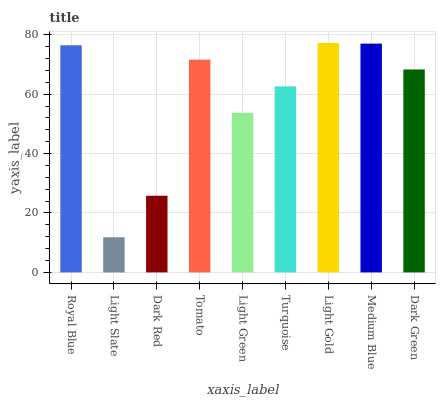Is Light Slate the minimum?
Answer yes or no. Yes. Is Light Gold the maximum?
Answer yes or no. Yes. Is Dark Red the minimum?
Answer yes or no. No. Is Dark Red the maximum?
Answer yes or no. No. Is Dark Red greater than Light Slate?
Answer yes or no. Yes. Is Light Slate less than Dark Red?
Answer yes or no. Yes. Is Light Slate greater than Dark Red?
Answer yes or no. No. Is Dark Red less than Light Slate?
Answer yes or no. No. Is Dark Green the high median?
Answer yes or no. Yes. Is Dark Green the low median?
Answer yes or no. Yes. Is Light Green the high median?
Answer yes or no. No. Is Tomato the low median?
Answer yes or no. No. 